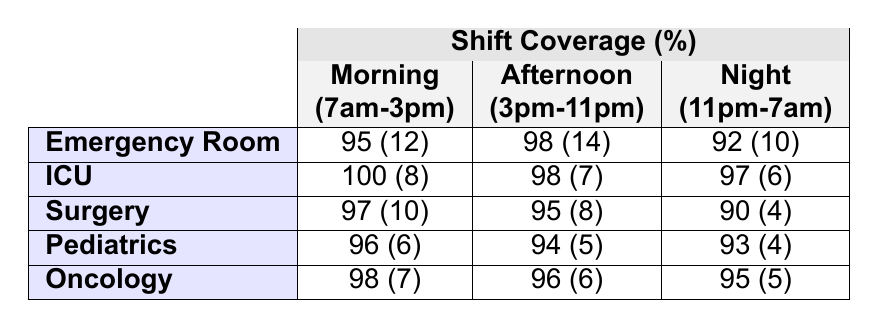What is the shift coverage percentage for the Emergency Room during the Night shift? The table indicates that the shift coverage percentage for the Emergency Room during the Night shift (11pm-7am) is 92.
Answer: 92 How many staff members are scheduled in the ICU for the Afternoon shift? From the table, the number of staff scheduled in the ICU for the Afternoon shift (3pm-11pm) is 7.
Answer: 7 Which unit has the highest number of staff scheduled for the Morning shift? The Emergency Room has 12 staff scheduled for the Morning shift, which is the highest among all units listed.
Answer: Emergency Room What is the average number of staff scheduled across all units during the Night shift? To find the average, we add the staff numbers for the Night shift (10 + 6 + 4 + 4 + 5 = 29) and divide by the number of units (5). Therefore, the average is 29 / 5 = 5.8.
Answer: 5.8 Is the shift coverage for the Surgery unit lower during the Night shift compared to the Morning shift? The Surgery unit has a shift coverage of 90% during the Night shift and 97% during the Morning shift, indicating that it is indeed lower at night.
Answer: Yes What is the total number of staff scheduled for the Morning shift across all units? The total staff for the Morning shift is 12 (Emergency Room) + 8 (ICU) + 10 (Surgery) + 6 (Pediatrics) + 7 (Oncology) = 43.
Answer: 43 Which unit has the lowest percentage of shift coverage during the Night shift? Examining the table, the Surgery unit has the lowest shift coverage percentage during the Night shift at 90%.
Answer: Surgery What is the difference in shift coverage percentage between ICU's Morning and Night shifts? ICU's Morning shift coverage is 100% and the Night shift is 97%, so the difference is 100 - 97 = 3%.
Answer: 3 If we add the staff scheduled during the Afternoon shift for Pediatrics and Oncology, what is the total? For the Afternoon shift, Pediatrics has 5 and Oncology has 6, so the total scheduled staff is 5 + 6 = 11.
Answer: 11 What percentage coverage exceeds 95% across all shifts in the Emergency Room? The Morning (95%), Afternoon (98%), and Night (92%) shifts yield the percentages that exceed 95%. Only the Afternoon shift exceeds 95%.
Answer: Afternoon (98%) 